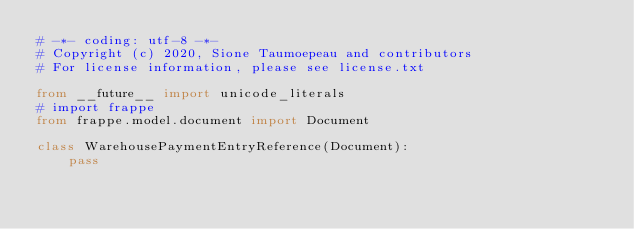<code> <loc_0><loc_0><loc_500><loc_500><_Python_># -*- coding: utf-8 -*-
# Copyright (c) 2020, Sione Taumoepeau and contributors
# For license information, please see license.txt

from __future__ import unicode_literals
# import frappe
from frappe.model.document import Document

class WarehousePaymentEntryReference(Document):
	pass
</code> 